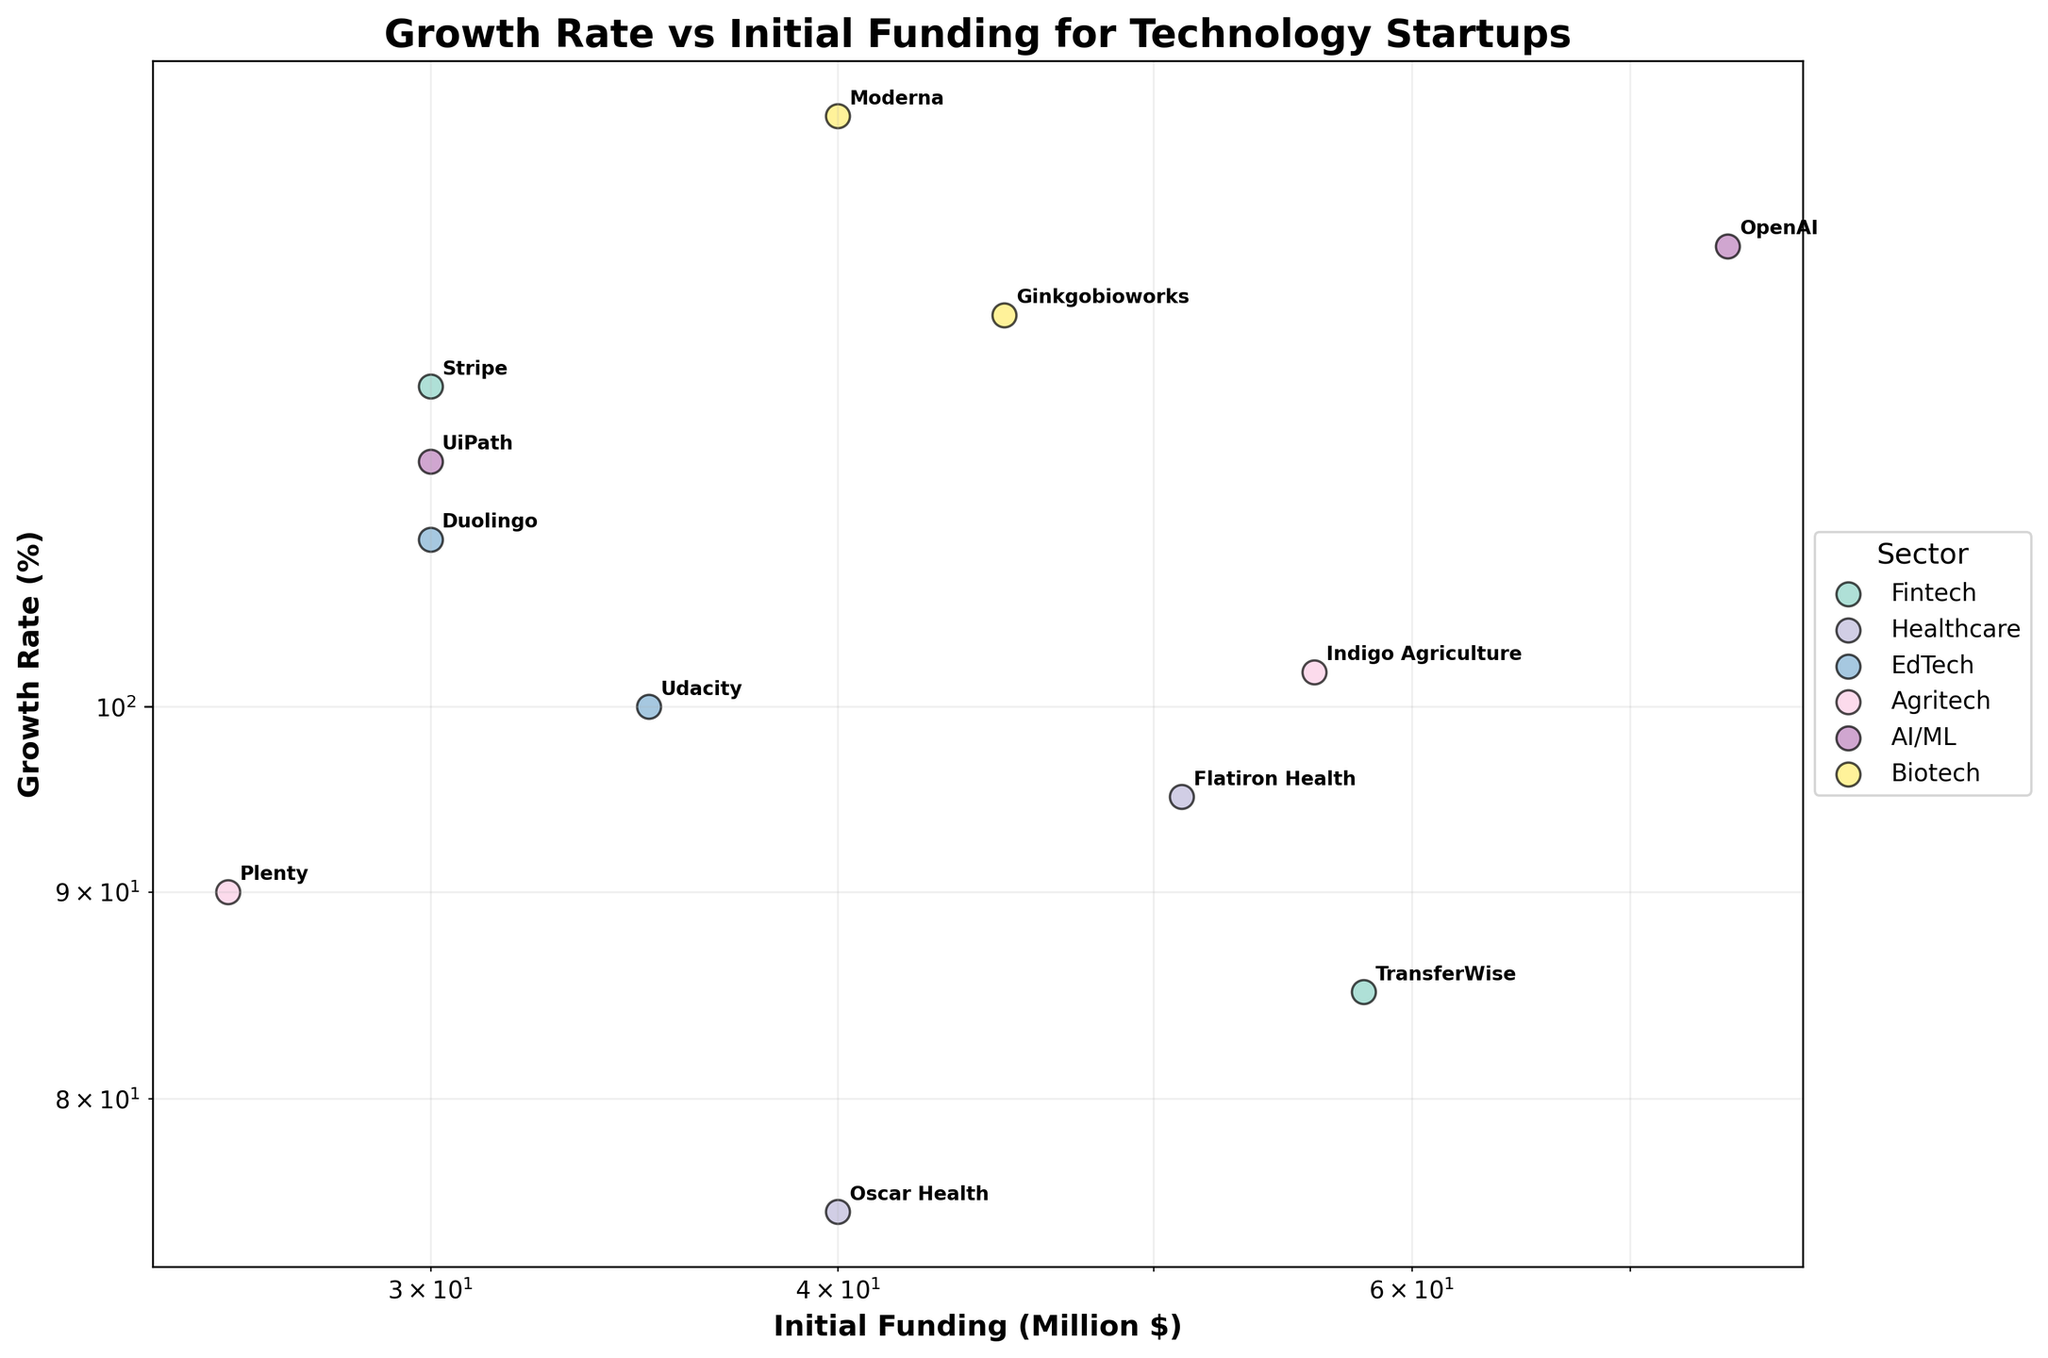How many sectors are represented in the plot? The plot shows different colors and labels for each sector. By counting the distinct colors and legend labels, we can determine the number of sectors. There are six legend entries representing the sectors: Fintech, Healthcare, EdTech, Agritech, AI/ML, and Biotech.
Answer: 6 Which company has the highest growth rate and what is its initial funding? By looking at the plot, we aim to find the company situated at the highest point on the y-axis. Moderna in the Biotech sector has the highest growth rate, marked at 140%, with an initial funding of $40 million.
Answer: Moderna, $40 million Which sector appears to have companies with relatively similar initial funding amounts? Visual assessment of the spread of data points along the x-axis for each sector helps. Both Fintech and EdTech sectors have relatively close initial funding amounts, observed around the $30 million to $58 million range for Fintech and $30 million to $35 million for EdTech.
Answer: Fintech and EdTech What is the average growth rate of companies in the AI/ML sector? To find the average growth rate, we first identify the AI/ML sector data points. The companies listed are OpenAI at 130% and UiPath at 115%. Adding these rates together gives 245%, and dividing by the number of companies (2) results in an average growth rate of 122.5%.
Answer: 122.5% Between Flatiron Health and TransferWise, which company had less initial funding and what is the difference? Flatiron Health and TransferWise are represented in the Healthcare and Fintech sectors respectively. Reading from the plot, TransferWise had $58 million, and Flatiron Health had $51 million. The difference is $58 million - $51 million = $7 million.
Answer: Flatiron Health, $7 million Which two sectors have overlapping growth rates but different ranges of initial funding? Identifying sectors with closely located data points vertically but differing horizontally can be determined from the plot. The EdTech and Agritech sectors show overlapping growth rates around the 90% to 110% range. However, initial funding ranges from $30–$35 million for EdTech and $26–$56 million for Agritech.
Answer: EdTech and Agritech What is the initial funding range observed for companies in the Healthcare sector? To find the range of initial funding in Healthcare, we look at the data points specific to the Healthcare sector. Oscar Health starts at $40 million and Flatiron Health at $51 million. Thus, the range of initial funding is from $40 million to $51 million.
Answer: $40 million to $51 million Comparing OpenAI and Duolingo, which company had a higher growth rate and by how much? By examining the plot points for OpenAI in the AI/ML sector and Duolingo in the EdTech sector, OpenAI had a growth rate of 130% and Duolingo had 110%. The difference in growth rate is 130% - 110% = 20%.
Answer: OpenAI, 20% What is the title of the plot? The title of the plot is directly provided at the top of the figure. It reads "Growth Rate vs Initial Funding for Technology Startups."
Answer: Growth Rate vs Initial Funding for Technology Startups Why might a log scale be used for the axes in this plot? Log scales are often used to better visualize data that spans several orders of magnitude, allowing smaller differences to be more easily observed. In this plot, log scales help manage the wide range of initial funding amounts and growth rates among the different companies.
Answer: To manage wide ranges in data 